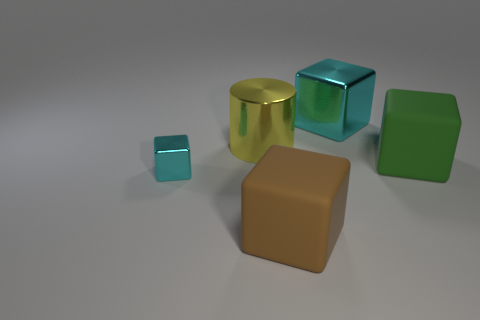Can you tell which object is in front of the others? The small turquoise cube appears to be in front of the other objects when viewing the image from this perspective. 